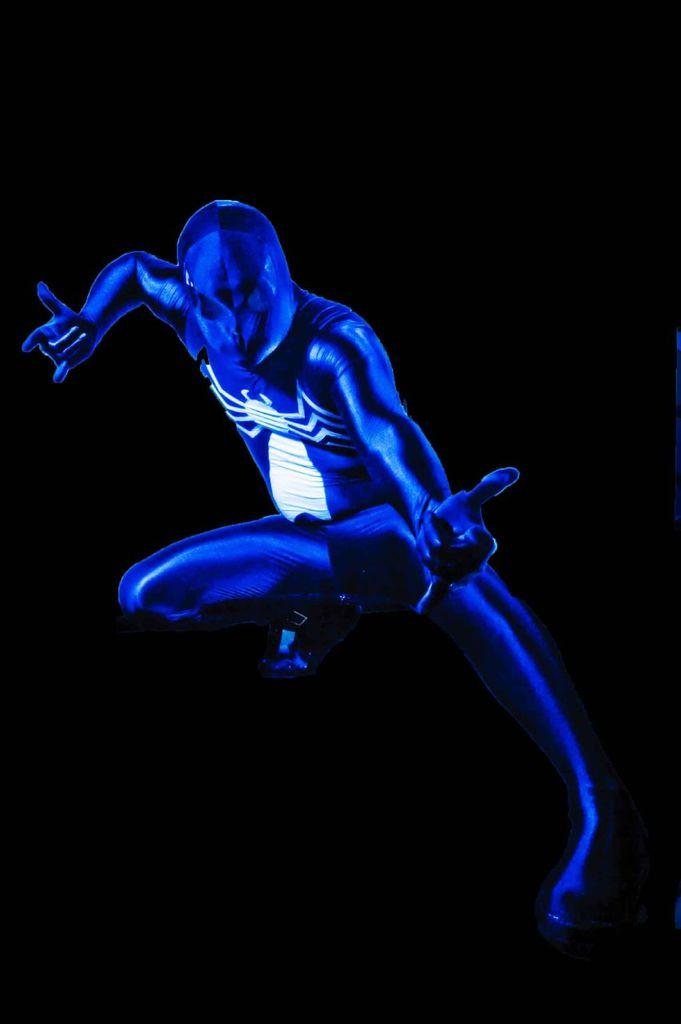What type of image is this? The image is animated. Can you describe the person in the image? The person in the image is wearing a blue suit. What is unique about the person's suit? The suit has a spider image. What can be said about the background of the image? The background of the image is dark. What type of wrench is being used by the person in the image? There is no wrench present in the image. What kind of furniture can be seen in the background of the image? There is no furniture visible in the image, as the background is dark. 